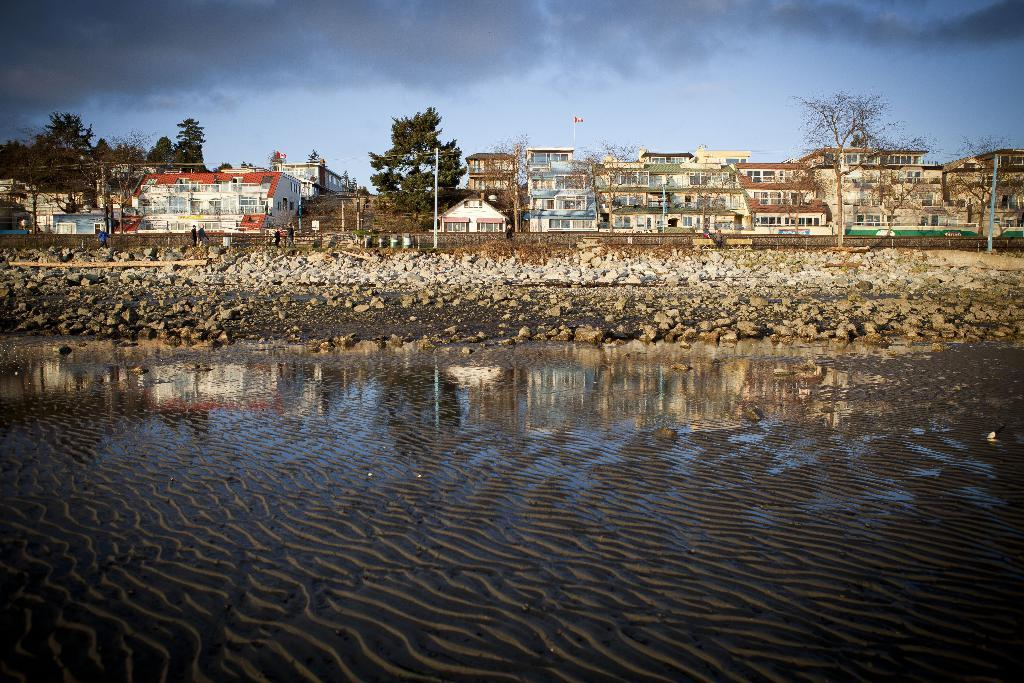What is the primary element visible in the image? There is water in the image. What can be seen in the distance behind the water? There are buildings, trees, poles, and the sky visible in the background of the image. How many different types of structures can be seen in the background? There are three different types of structures visible in the background: buildings, poles, and trees. What type of marble is being played in the background of the image? There is no marble or music being played in the image; it only features water and structures in the background. 